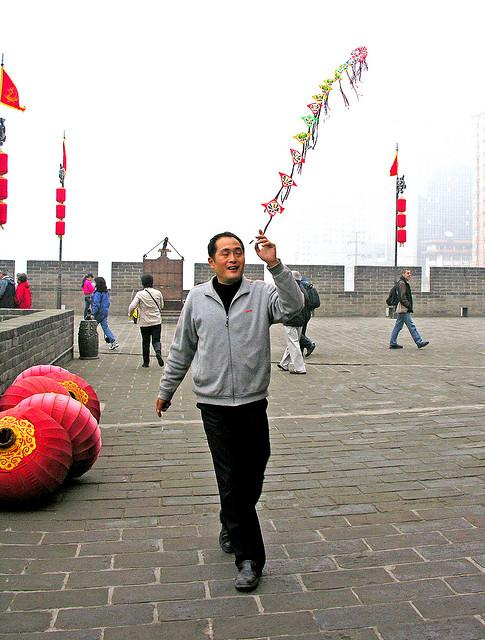The man closest to the right has what kind of pants on? Please explain your reasoning. jeans. The man's pants are blue. blue denim is the most common material from which jeans are made. 